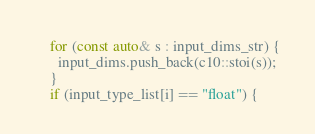Convert code to text. <code><loc_0><loc_0><loc_500><loc_500><_ObjectiveC_>    for (const auto& s : input_dims_str) {
      input_dims.push_back(c10::stoi(s));
    }
    if (input_type_list[i] == "float") {</code> 